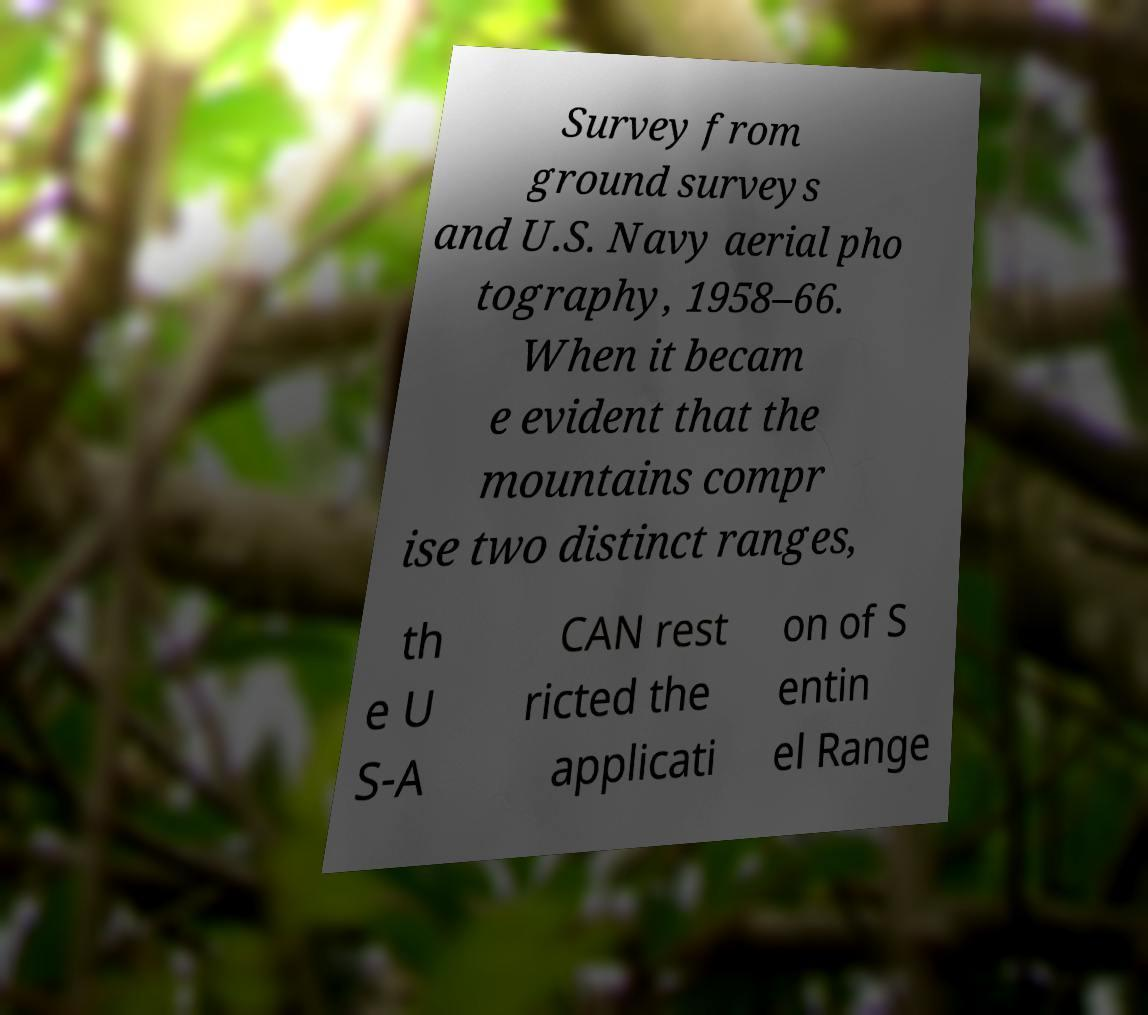There's text embedded in this image that I need extracted. Can you transcribe it verbatim? Survey from ground surveys and U.S. Navy aerial pho tography, 1958–66. When it becam e evident that the mountains compr ise two distinct ranges, th e U S-A CAN rest ricted the applicati on of S entin el Range 